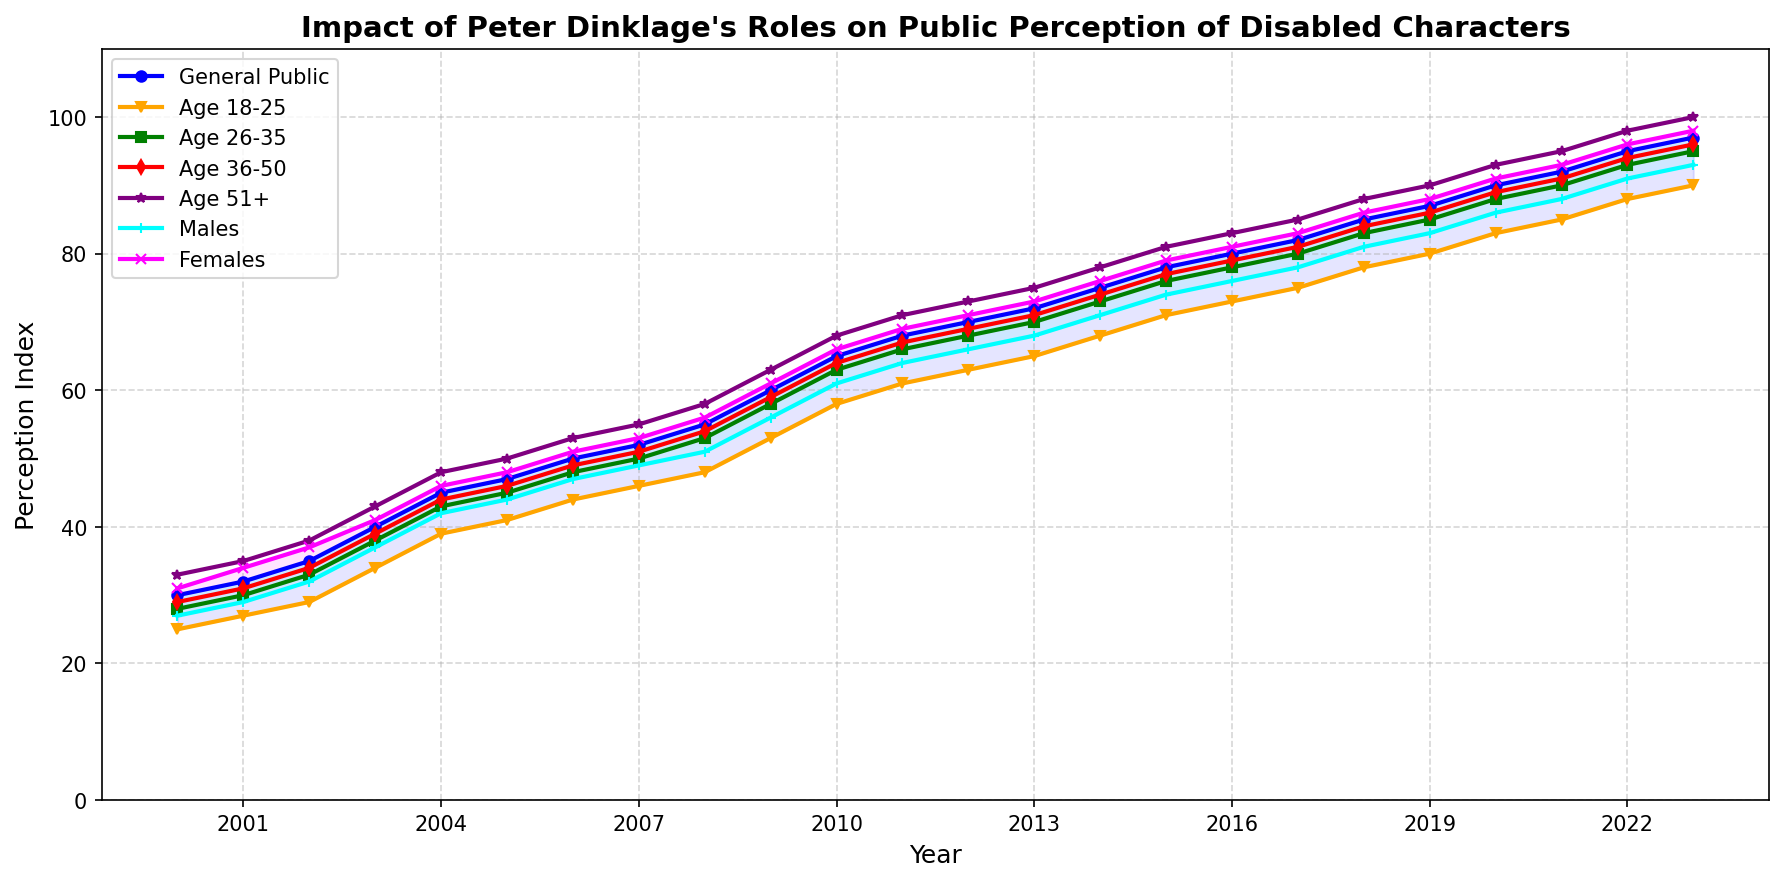what trend can we observe in public perception from 2000 to 2023? The line chart shows a consistent upward trend in the public perception of disabled characters from 2000 to 2023. The general public perception improves from 30 in 2000 to 97 in 2023, indicating a continuous positive impact.
Answer: Continuous upward trend Which year saw the largest increase in public perception among the general public? By examining the steepness of the general public line, the year 2003 shows a significant jump from 35 to 40, the largest increase in a single year.
Answer: 2003 By how much did public perception improve for the 18-25 age group from 2000 to 2023? To find the improvement, subtract the value in 2000 (25) from the value in 2023 (90). The calculation is 90 - 25 = 65.
Answer: 65 Which demographic group had the highest perception index in 2023, and what was its value? The age group 51+ had the highest perception index in 2023. Looking at the end of the line for this age group, it reaches 100.
Answer: Age 51+, 100 In which year did females' perception surpass that of males and what were the values? By comparing the 'Females' and 'Males' lines, females' perception surpasses males' perception in 2001 with values of 34 for females and 29 for males.
Answer: 2001; 34 and 29 Which two demographic groups had the smallest difference in perception in 2020? To find the smallest difference in 2020, compare the values: 
- Age 18-25: 83
- Age 26-35: 88
- Age 36-50: 89
- Age 51+: 93
- Males: 86
- Females: 91
The small differences are between Age 26-35 and Age 36-50 (1), and Males and Age 18-25 (3). Therefore, Age 26-35 and Age 36-50 had the smallest difference of 1.
Answer: Age 26-35 and Age 36-50; difference of 1 Between which years was the perception gap between males and females consistent? The perception gap between males and females remained relatively consistent between 2010 and 2015, where females remained consistently higher by around 5 points.
Answer: 2010-2015 In 2015, what was the sum of perception indexes for the age groups 18-25 and 51+? For 2015, add the values for Age 18-25 (71) and Age 51+ (81). The calculation is 71 + 81 = 152.
Answer: 152 Identify the two years where the perception indexes for all groups showed the same directional change? All groups showed an upward trend from 2002 to 2003 and from 2017 to 2018, where each group’s perception index increased.
Answer: 2002 to 2003, 2017 to 2018 By how much did the general public's perception improve from 2010 to 2023, and what was the average annual increase? The improvement from 2010 (65) to 2023 (97) is: 97 - 65 = 32. The period is 13 years, so the average annual increase is: 32 / 13 ≈ 2.46.
Answer: 32, 2.46 